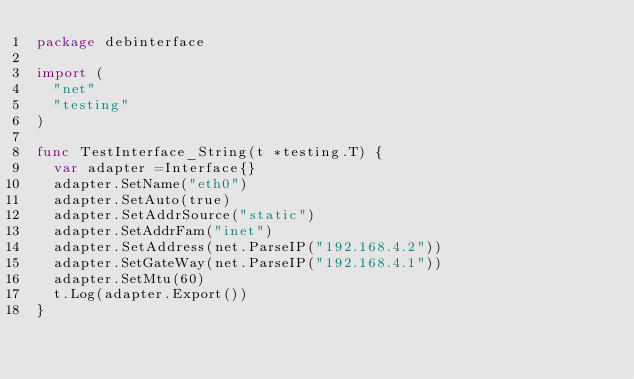<code> <loc_0><loc_0><loc_500><loc_500><_Go_>package debinterface

import (
	"net"
	"testing"
)

func TestInterface_String(t *testing.T) {
	var adapter =Interface{}
	adapter.SetName("eth0")
	adapter.SetAuto(true)
	adapter.SetAddrSource("static")
	adapter.SetAddrFam("inet")
	adapter.SetAddress(net.ParseIP("192.168.4.2"))
	adapter.SetGateWay(net.ParseIP("192.168.4.1"))
	adapter.SetMtu(60)
	t.Log(adapter.Export())
}
</code> 